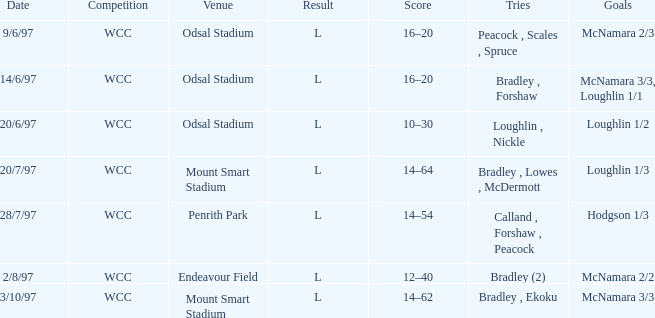What were the endeavors undertaken on 6/14/97? Bradley , Forshaw. 